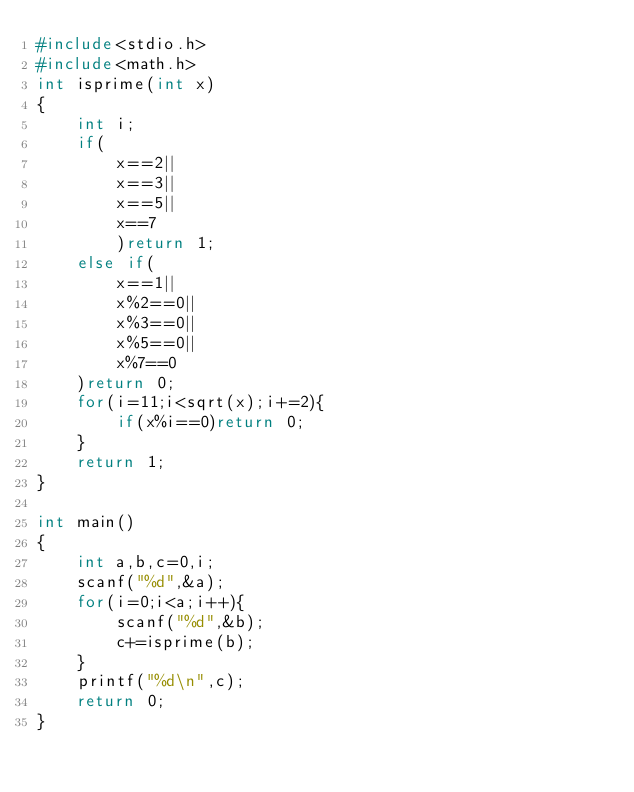<code> <loc_0><loc_0><loc_500><loc_500><_C_>#include<stdio.h>
#include<math.h>
int isprime(int x)
{
    int i;
    if(
        x==2||
        x==3||
        x==5||
        x==7
        )return 1;
    else if(
        x==1||
        x%2==0||
        x%3==0||
        x%5==0||
        x%7==0
    )return 0;
    for(i=11;i<sqrt(x);i+=2){
        if(x%i==0)return 0;
    }
    return 1;
}

int main()
{
    int a,b,c=0,i;
    scanf("%d",&a);
    for(i=0;i<a;i++){
        scanf("%d",&b);
        c+=isprime(b);
    }
    printf("%d\n",c);
    return 0;
}</code> 